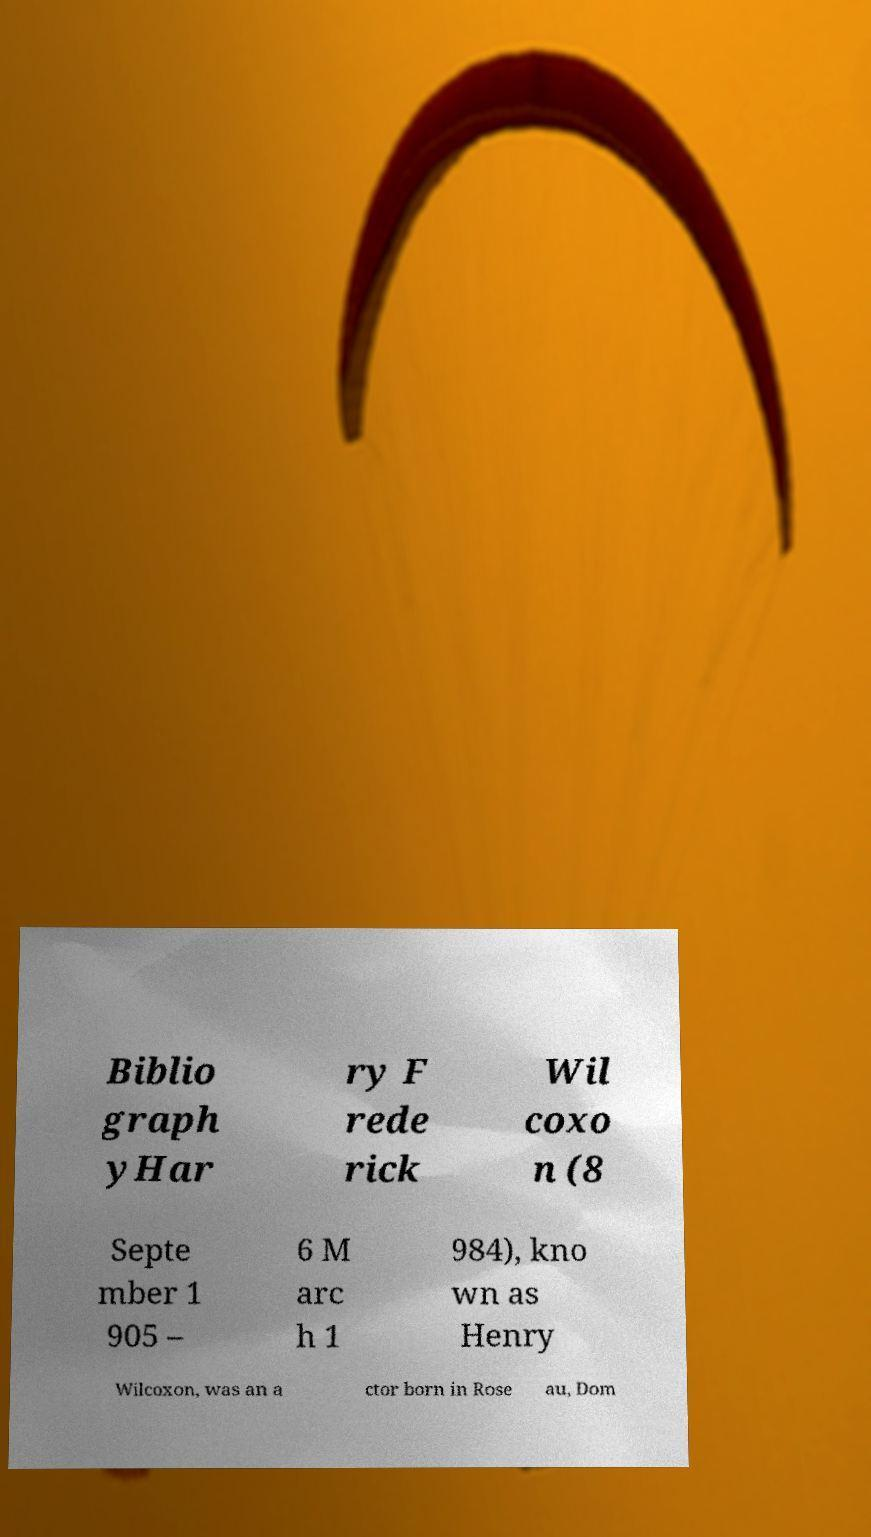I need the written content from this picture converted into text. Can you do that? Biblio graph yHar ry F rede rick Wil coxo n (8 Septe mber 1 905 – 6 M arc h 1 984), kno wn as Henry Wilcoxon, was an a ctor born in Rose au, Dom 